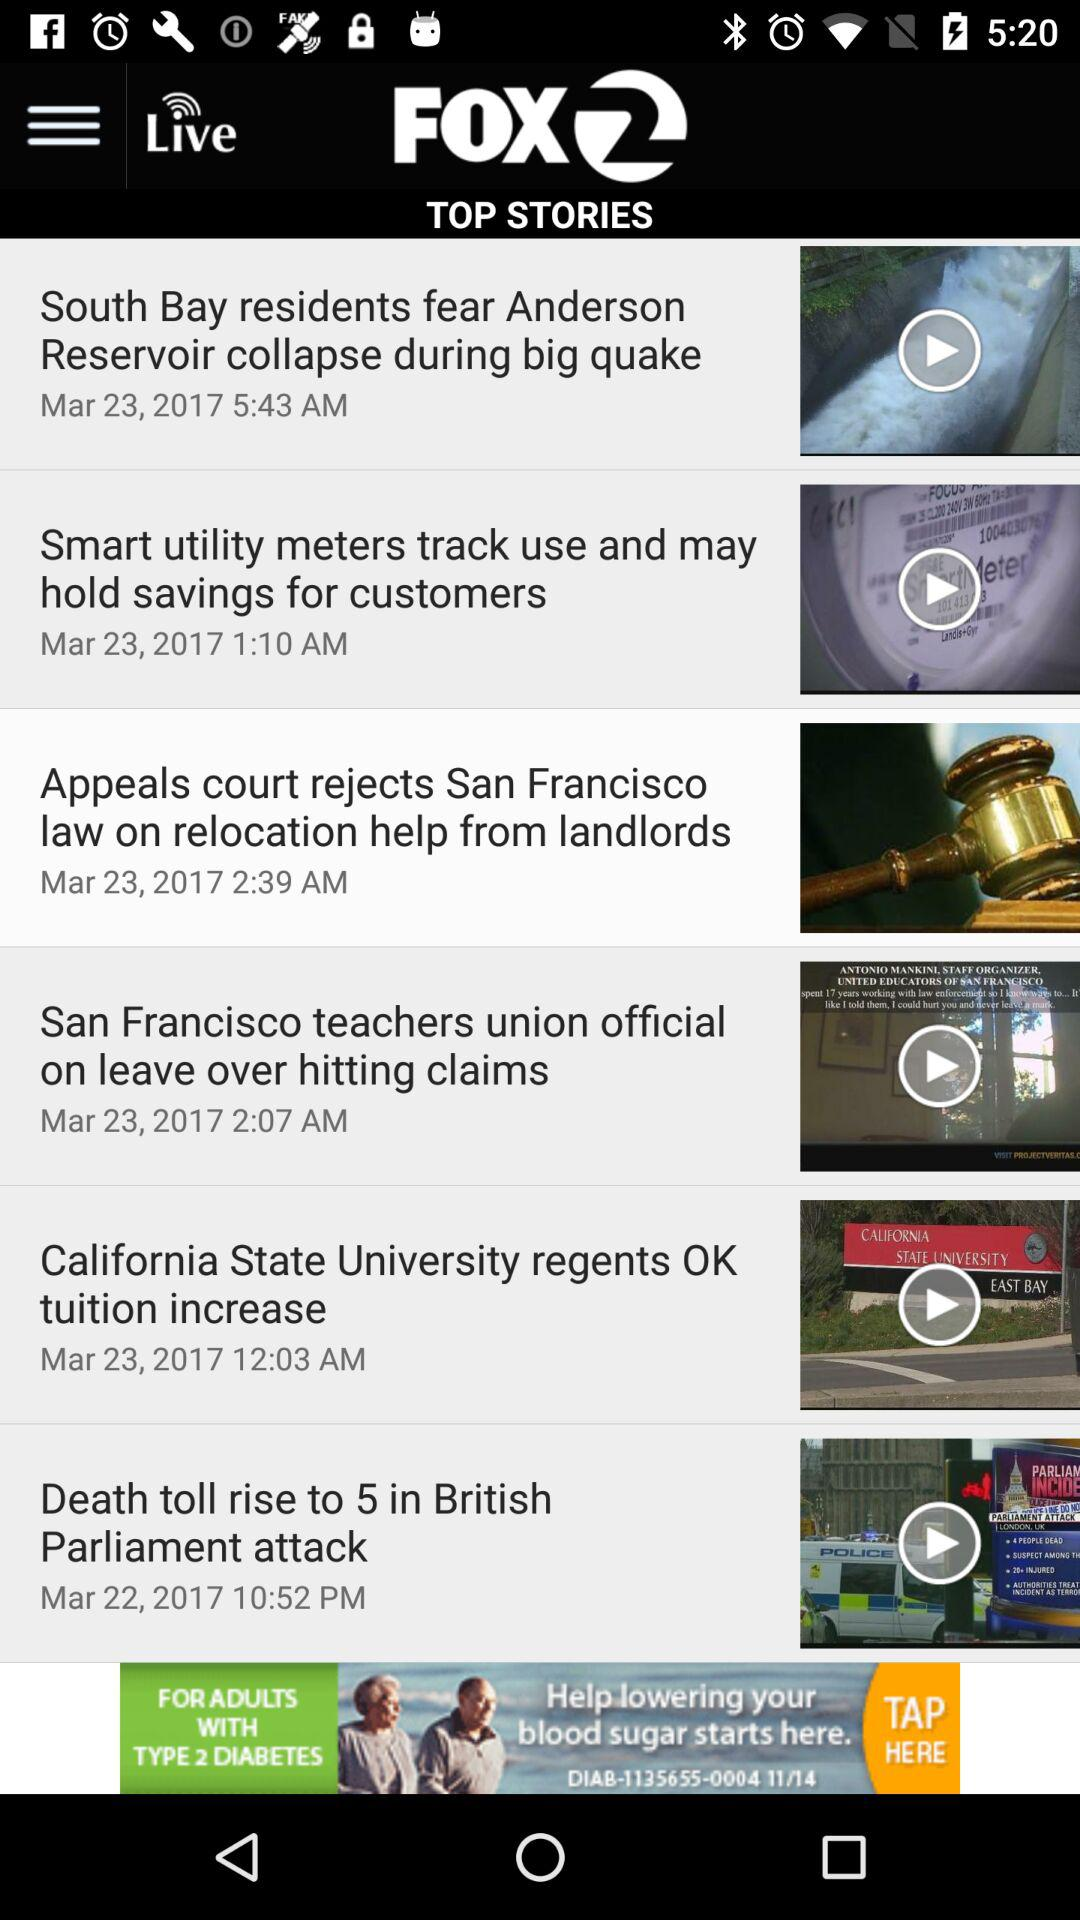How many news stories are there?
Answer the question using a single word or phrase. 6 